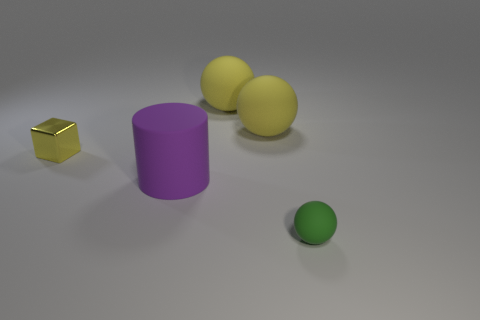How many objects are there in total, and can you describe their colors? There are four objects in total. Starting from the left, there's a small reflective gold cube, a large matte purple cylinder, two identical matte yellow spheres, and a small matte green sphere in the foreground. 